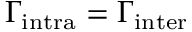<formula> <loc_0><loc_0><loc_500><loc_500>\Gamma _ { i n t r a } = \Gamma _ { i n t e r }</formula> 